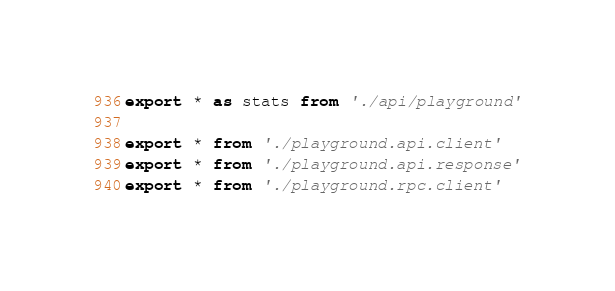Convert code to text. <code><loc_0><loc_0><loc_500><loc_500><_TypeScript_>export * as stats from './api/playground'

export * from './playground.api.client'
export * from './playground.api.response'
export * from './playground.rpc.client'
</code> 